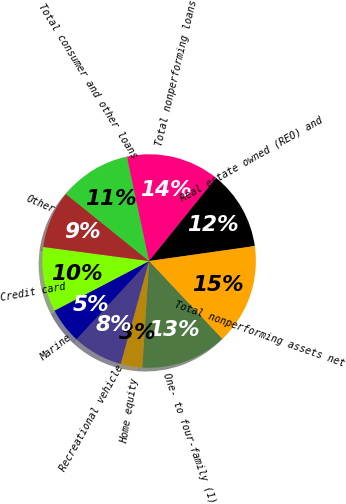Convert chart to OTSL. <chart><loc_0><loc_0><loc_500><loc_500><pie_chart><fcel>One- to four-family (1)<fcel>Home equity<fcel>Recreational vehicle<fcel>Marine<fcel>Credit card<fcel>Other<fcel>Total consumer and other loans<fcel>Total nonperforming loans<fcel>Real estate owned (REO) and<fcel>Total nonperforming assets net<nl><fcel>13.04%<fcel>3.26%<fcel>7.61%<fcel>5.43%<fcel>9.78%<fcel>8.7%<fcel>10.87%<fcel>14.13%<fcel>11.96%<fcel>15.22%<nl></chart> 